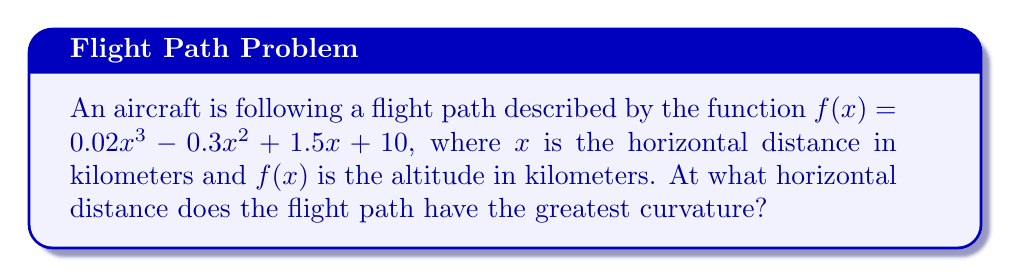What is the answer to this math problem? To find the point of greatest curvature, we need to analyze the second derivative of the flight path function. The steps are as follows:

1. Find the first derivative:
   $f'(x) = 0.06x^2 - 0.6x + 1.5$

2. Find the second derivative:
   $f''(x) = 0.12x - 0.6$

3. The curvature is given by the formula:
   $\kappa = \frac{|f''(x)|}{(1 + (f'(x))^2)^{3/2}}$

4. The point of greatest curvature occurs where $|f''(x)|$ is maximum (since the denominator is always positive).

5. $|f''(x)|$ is maximum when $f''(x)$ is either at its maximum or minimum value.

6. To find the extremum of $f''(x)$, we set its derivative to zero:
   $\frac{d}{dx}f''(x) = 0.12 = 0$

7. Since this is always positive, $f''(x)$ has no local maximum or minimum.

8. Therefore, the maximum curvature occurs at the endpoint where $|f''(x)|$ is largest.

9. We need to compare $|f''(x)|$ at the endpoints of the reasonable domain (e.g., 0 to 100 km):
   At $x = 0$: $|f''(0)| = |-0.6| = 0.6$
   At $x = 100$: $|f''(100)| = |11.4| = 11.4$

10. The larger value occurs at $x = 100$ km.
Answer: 100 km 